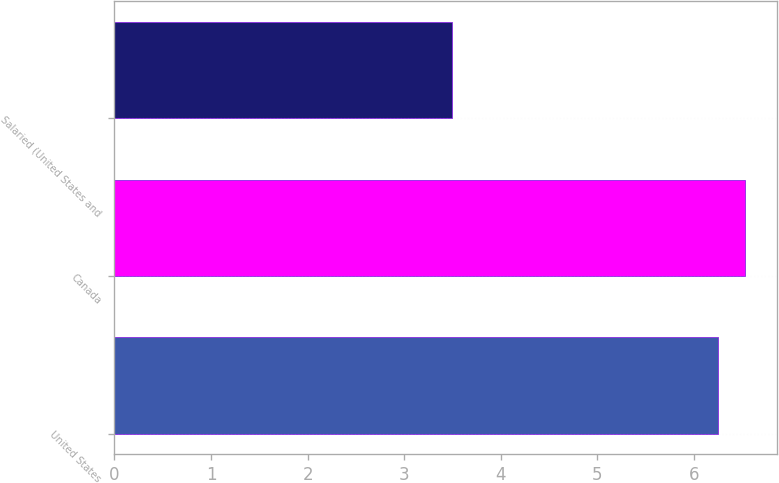<chart> <loc_0><loc_0><loc_500><loc_500><bar_chart><fcel>United States<fcel>Canada<fcel>Salaried (United States and<nl><fcel>6.25<fcel>6.53<fcel>3.5<nl></chart> 